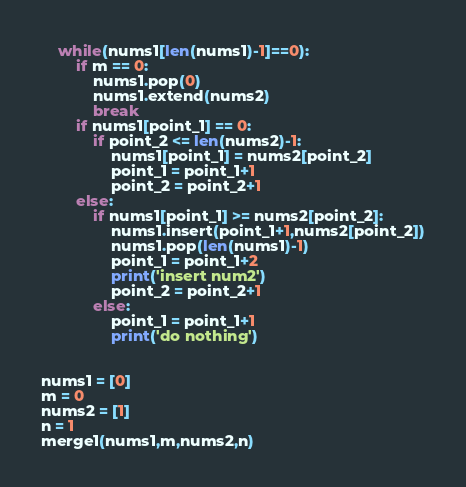<code> <loc_0><loc_0><loc_500><loc_500><_Python_>    while(nums1[len(nums1)-1]==0):
        if m == 0:
            nums1.pop(0)
            nums1.extend(nums2)
            break
        if nums1[point_1] == 0:
            if point_2 <= len(nums2)-1:
                nums1[point_1] = nums2[point_2]
                point_1 = point_1+1
                point_2 = point_2+1
        else:
            if nums1[point_1] >= nums2[point_2]:
                nums1.insert(point_1+1,nums2[point_2])
                nums1.pop(len(nums1)-1)
                point_1 = point_1+2
                print('insert num2')
                point_2 = point_2+1
            else:
                point_1 = point_1+1
                print('do nothing')
        
    
nums1 = [0]
m = 0
nums2 = [1]
n = 1
merge1(nums1,m,nums2,n)</code> 